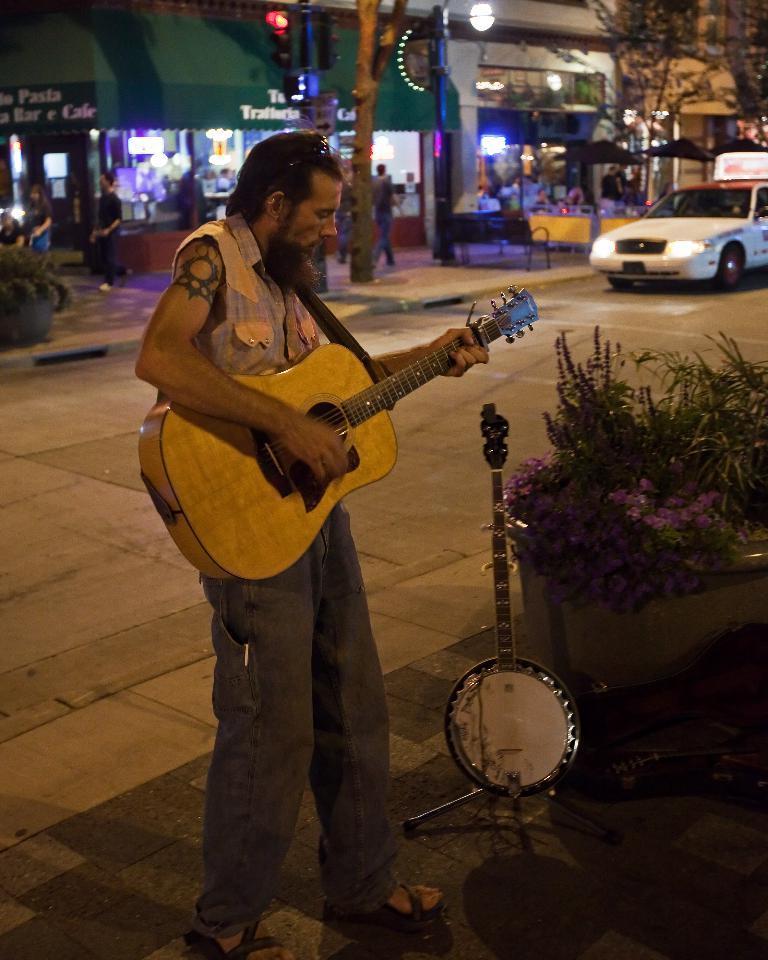How would you summarize this image in a sentence or two? This is a picture where a person holding a guitar and playing it beside him there are some plants and flowers and behind him there are some shops and a signal and a pole which has a light and also a car on the road. 